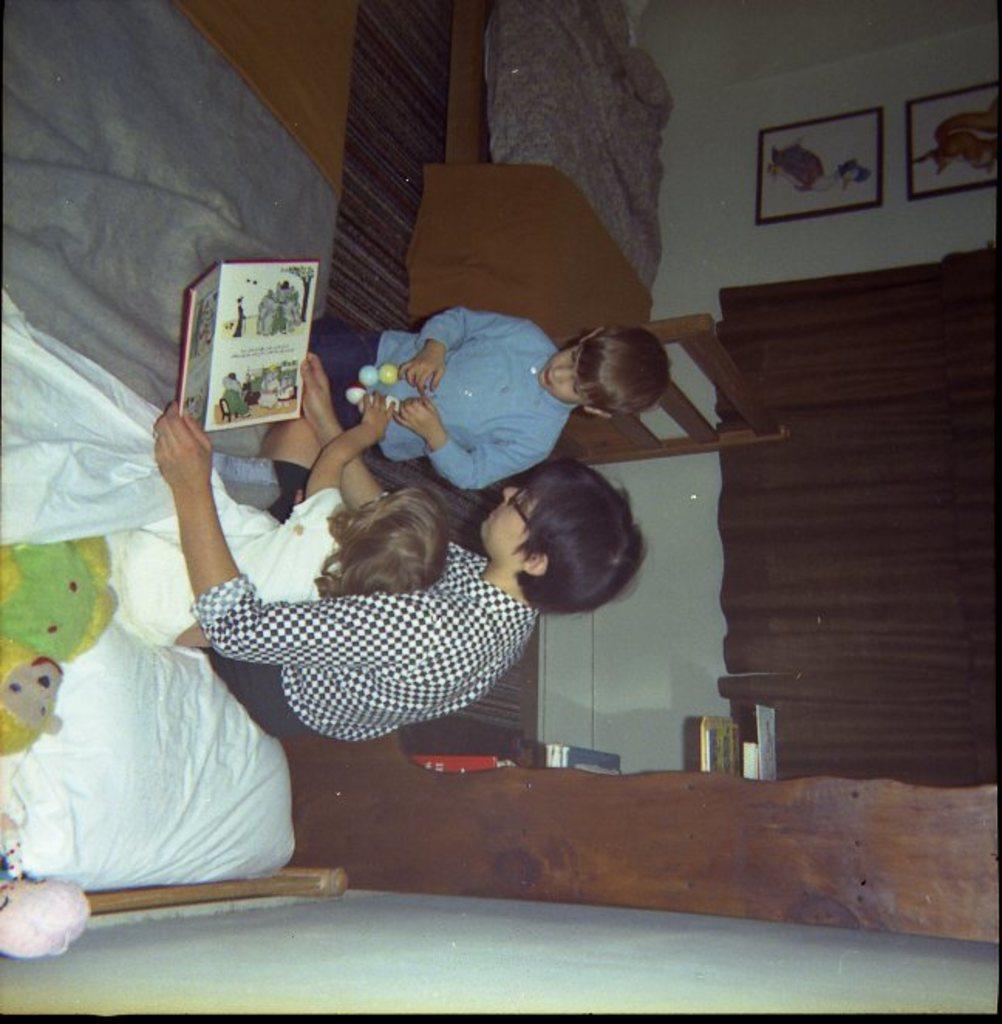Can you describe this image briefly? In this picture I can see a girl and a person holding a book and sitting on the bed and I can see a boy standing and holding a toy in his hands. I can see a soft toy at the bottom of the picture and a pillow at the bottom right corner and I can see another bed in the back and couple of photo frames on the wall. I can see curtains and few books on the shelves. 